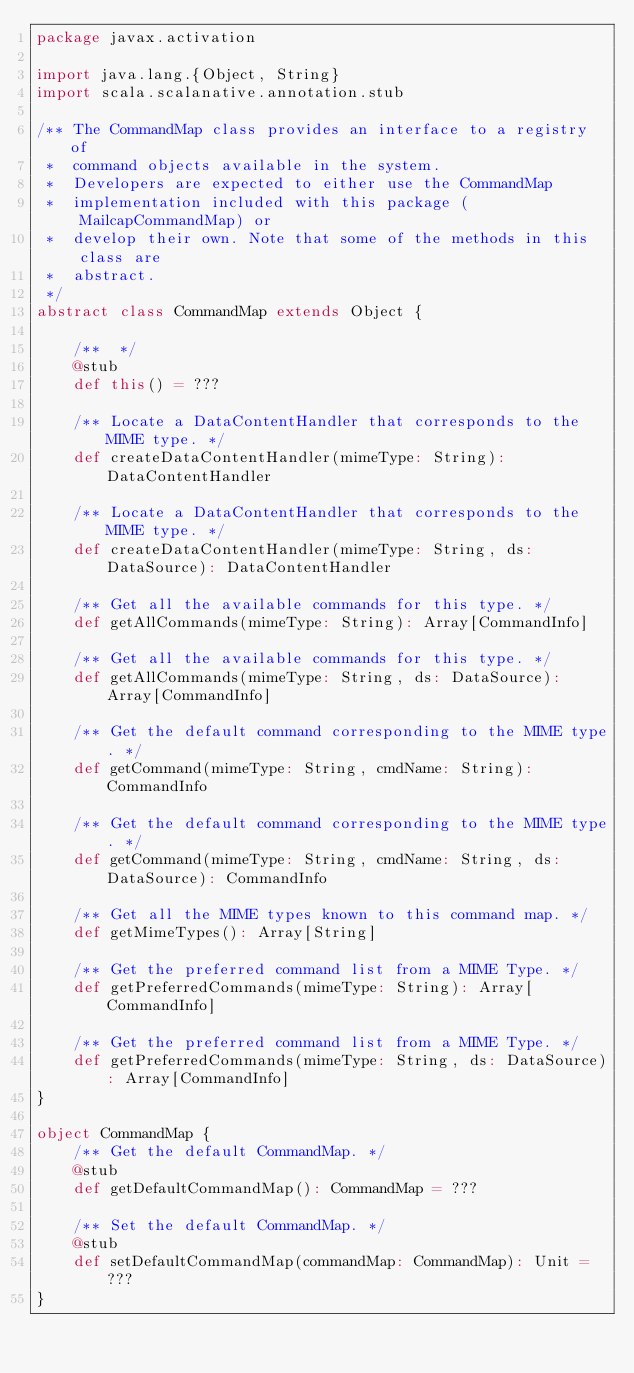Convert code to text. <code><loc_0><loc_0><loc_500><loc_500><_Scala_>package javax.activation

import java.lang.{Object, String}
import scala.scalanative.annotation.stub

/** The CommandMap class provides an interface to a registry of
 *  command objects available in the system.
 *  Developers are expected to either use the CommandMap
 *  implementation included with this package (MailcapCommandMap) or
 *  develop their own. Note that some of the methods in this class are
 *  abstract.
 */
abstract class CommandMap extends Object {

    /**  */
    @stub
    def this() = ???

    /** Locate a DataContentHandler that corresponds to the MIME type. */
    def createDataContentHandler(mimeType: String): DataContentHandler

    /** Locate a DataContentHandler that corresponds to the MIME type. */
    def createDataContentHandler(mimeType: String, ds: DataSource): DataContentHandler

    /** Get all the available commands for this type. */
    def getAllCommands(mimeType: String): Array[CommandInfo]

    /** Get all the available commands for this type. */
    def getAllCommands(mimeType: String, ds: DataSource): Array[CommandInfo]

    /** Get the default command corresponding to the MIME type. */
    def getCommand(mimeType: String, cmdName: String): CommandInfo

    /** Get the default command corresponding to the MIME type. */
    def getCommand(mimeType: String, cmdName: String, ds: DataSource): CommandInfo

    /** Get all the MIME types known to this command map. */
    def getMimeTypes(): Array[String]

    /** Get the preferred command list from a MIME Type. */
    def getPreferredCommands(mimeType: String): Array[CommandInfo]

    /** Get the preferred command list from a MIME Type. */
    def getPreferredCommands(mimeType: String, ds: DataSource): Array[CommandInfo]
}

object CommandMap {
    /** Get the default CommandMap. */
    @stub
    def getDefaultCommandMap(): CommandMap = ???

    /** Set the default CommandMap. */
    @stub
    def setDefaultCommandMap(commandMap: CommandMap): Unit = ???
}
</code> 